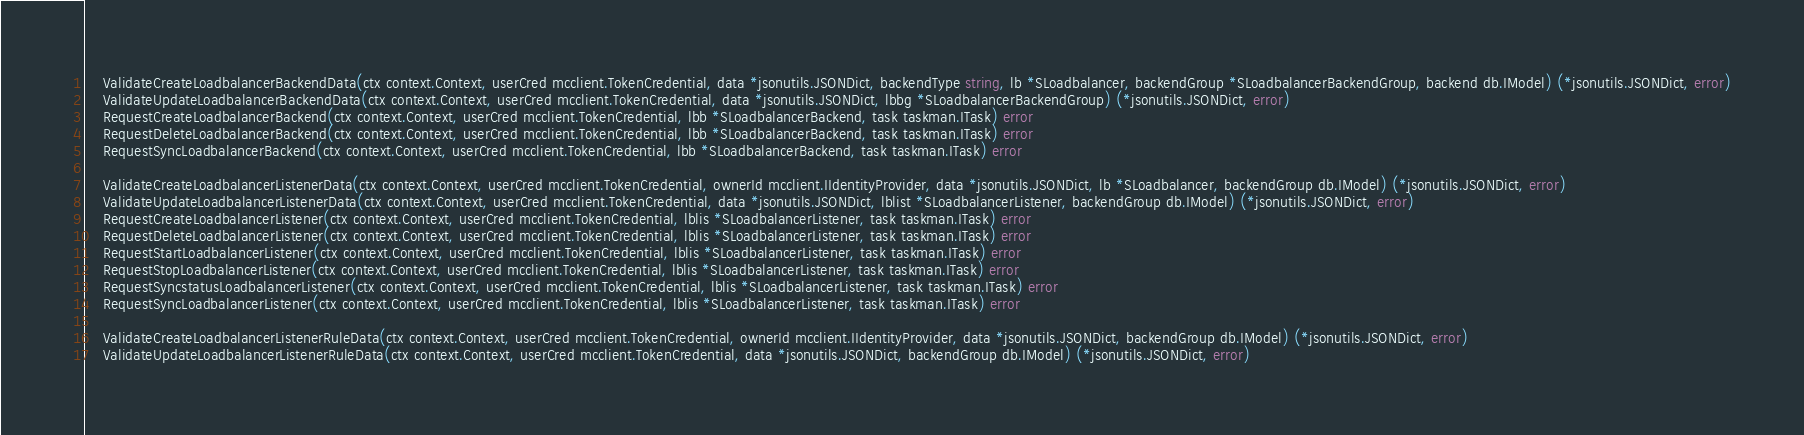Convert code to text. <code><loc_0><loc_0><loc_500><loc_500><_Go_>	ValidateCreateLoadbalancerBackendData(ctx context.Context, userCred mcclient.TokenCredential, data *jsonutils.JSONDict, backendType string, lb *SLoadbalancer, backendGroup *SLoadbalancerBackendGroup, backend db.IModel) (*jsonutils.JSONDict, error)
	ValidateUpdateLoadbalancerBackendData(ctx context.Context, userCred mcclient.TokenCredential, data *jsonutils.JSONDict, lbbg *SLoadbalancerBackendGroup) (*jsonutils.JSONDict, error)
	RequestCreateLoadbalancerBackend(ctx context.Context, userCred mcclient.TokenCredential, lbb *SLoadbalancerBackend, task taskman.ITask) error
	RequestDeleteLoadbalancerBackend(ctx context.Context, userCred mcclient.TokenCredential, lbb *SLoadbalancerBackend, task taskman.ITask) error
	RequestSyncLoadbalancerBackend(ctx context.Context, userCred mcclient.TokenCredential, lbb *SLoadbalancerBackend, task taskman.ITask) error

	ValidateCreateLoadbalancerListenerData(ctx context.Context, userCred mcclient.TokenCredential, ownerId mcclient.IIdentityProvider, data *jsonutils.JSONDict, lb *SLoadbalancer, backendGroup db.IModel) (*jsonutils.JSONDict, error)
	ValidateUpdateLoadbalancerListenerData(ctx context.Context, userCred mcclient.TokenCredential, data *jsonutils.JSONDict, lblist *SLoadbalancerListener, backendGroup db.IModel) (*jsonutils.JSONDict, error)
	RequestCreateLoadbalancerListener(ctx context.Context, userCred mcclient.TokenCredential, lblis *SLoadbalancerListener, task taskman.ITask) error
	RequestDeleteLoadbalancerListener(ctx context.Context, userCred mcclient.TokenCredential, lblis *SLoadbalancerListener, task taskman.ITask) error
	RequestStartLoadbalancerListener(ctx context.Context, userCred mcclient.TokenCredential, lblis *SLoadbalancerListener, task taskman.ITask) error
	RequestStopLoadbalancerListener(ctx context.Context, userCred mcclient.TokenCredential, lblis *SLoadbalancerListener, task taskman.ITask) error
	RequestSyncstatusLoadbalancerListener(ctx context.Context, userCred mcclient.TokenCredential, lblis *SLoadbalancerListener, task taskman.ITask) error
	RequestSyncLoadbalancerListener(ctx context.Context, userCred mcclient.TokenCredential, lblis *SLoadbalancerListener, task taskman.ITask) error

	ValidateCreateLoadbalancerListenerRuleData(ctx context.Context, userCred mcclient.TokenCredential, ownerId mcclient.IIdentityProvider, data *jsonutils.JSONDict, backendGroup db.IModel) (*jsonutils.JSONDict, error)
	ValidateUpdateLoadbalancerListenerRuleData(ctx context.Context, userCred mcclient.TokenCredential, data *jsonutils.JSONDict, backendGroup db.IModel) (*jsonutils.JSONDict, error)</code> 